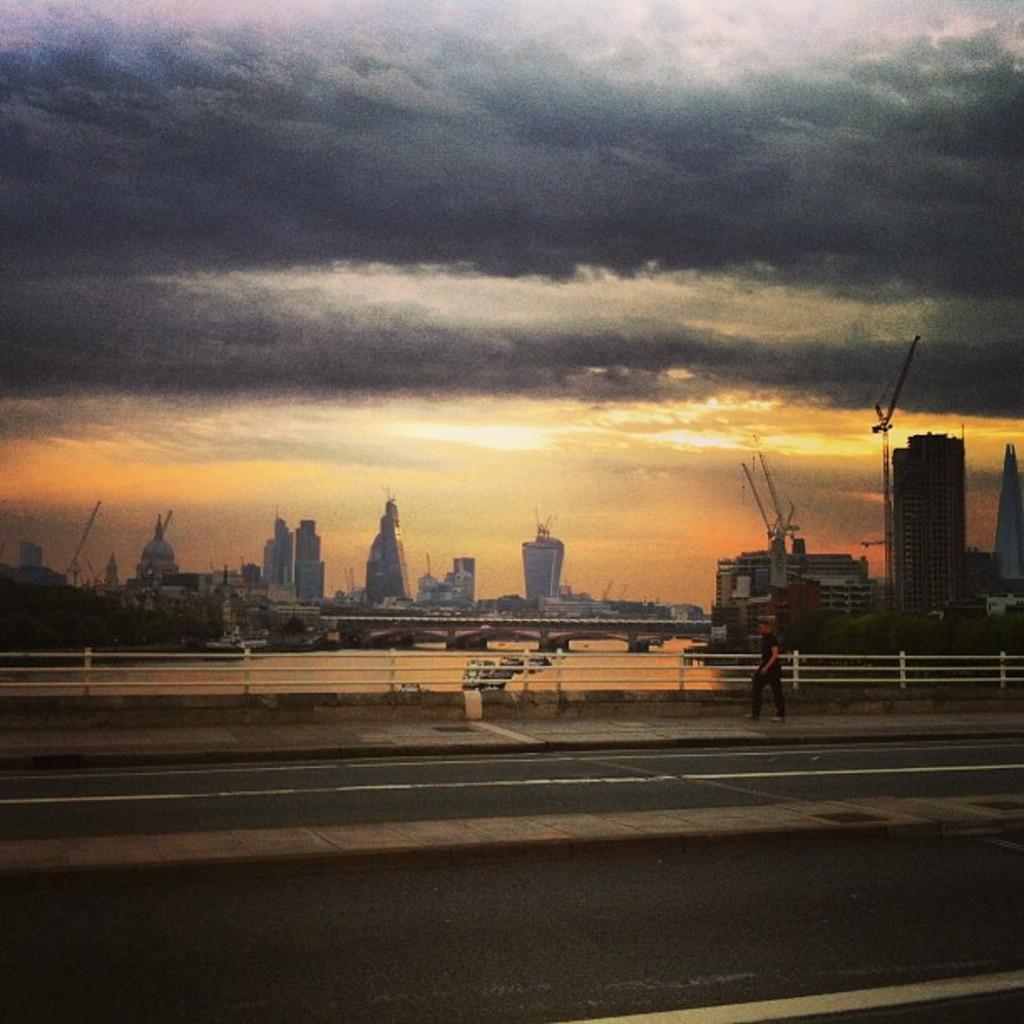In one or two sentences, can you explain what this image depicts? In this image I can see the road. To the side of the road I can see the person walking and there is a railing. In the background I can see the trees and many buildings. I can also see the clouds and the sky in the back. 